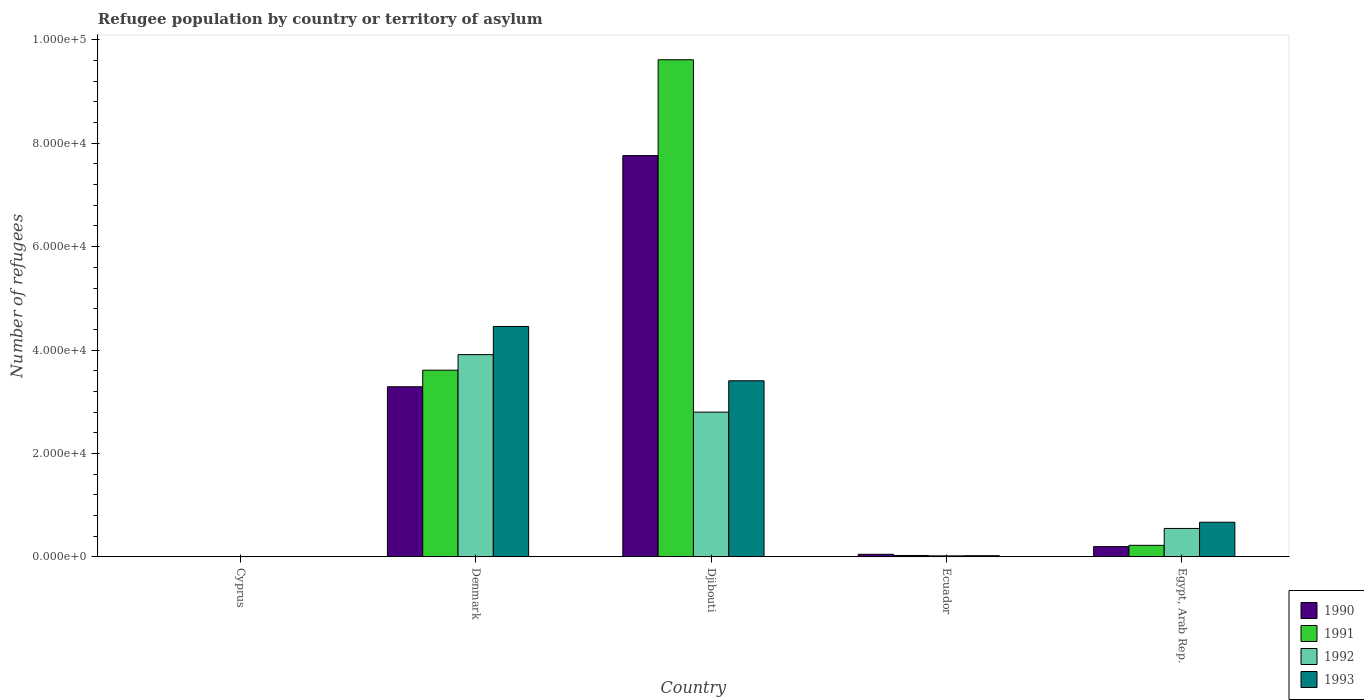How many different coloured bars are there?
Offer a very short reply. 4. How many groups of bars are there?
Make the answer very short. 5. Are the number of bars on each tick of the X-axis equal?
Offer a very short reply. Yes. How many bars are there on the 1st tick from the right?
Your response must be concise. 4. What is the label of the 1st group of bars from the left?
Offer a terse response. Cyprus. What is the number of refugees in 1992 in Djibouti?
Make the answer very short. 2.80e+04. Across all countries, what is the maximum number of refugees in 1990?
Offer a very short reply. 7.76e+04. Across all countries, what is the minimum number of refugees in 1993?
Keep it short and to the point. 82. In which country was the number of refugees in 1990 maximum?
Your response must be concise. Djibouti. In which country was the number of refugees in 1990 minimum?
Keep it short and to the point. Cyprus. What is the total number of refugees in 1991 in the graph?
Your response must be concise. 1.35e+05. What is the difference between the number of refugees in 1992 in Djibouti and that in Ecuador?
Offer a very short reply. 2.78e+04. What is the difference between the number of refugees in 1991 in Djibouti and the number of refugees in 1993 in Ecuador?
Your answer should be compact. 9.59e+04. What is the average number of refugees in 1993 per country?
Your answer should be compact. 1.71e+04. What is the difference between the number of refugees of/in 1992 and number of refugees of/in 1990 in Egypt, Arab Rep.?
Make the answer very short. 3518. What is the ratio of the number of refugees in 1990 in Djibouti to that in Egypt, Arab Rep.?
Make the answer very short. 38.98. Is the number of refugees in 1993 in Denmark less than that in Djibouti?
Your answer should be very brief. No. Is the difference between the number of refugees in 1992 in Djibouti and Egypt, Arab Rep. greater than the difference between the number of refugees in 1990 in Djibouti and Egypt, Arab Rep.?
Offer a terse response. No. What is the difference between the highest and the second highest number of refugees in 1991?
Give a very brief answer. 9.39e+04. What is the difference between the highest and the lowest number of refugees in 1993?
Make the answer very short. 4.45e+04. In how many countries, is the number of refugees in 1990 greater than the average number of refugees in 1990 taken over all countries?
Keep it short and to the point. 2. Is the sum of the number of refugees in 1991 in Denmark and Ecuador greater than the maximum number of refugees in 1990 across all countries?
Provide a succinct answer. No. Is it the case that in every country, the sum of the number of refugees in 1993 and number of refugees in 1991 is greater than the sum of number of refugees in 1992 and number of refugees in 1990?
Make the answer very short. No. What does the 4th bar from the left in Denmark represents?
Offer a terse response. 1993. Is it the case that in every country, the sum of the number of refugees in 1993 and number of refugees in 1992 is greater than the number of refugees in 1991?
Offer a terse response. No. How many bars are there?
Make the answer very short. 20. Are all the bars in the graph horizontal?
Make the answer very short. No. What is the difference between two consecutive major ticks on the Y-axis?
Keep it short and to the point. 2.00e+04. Are the values on the major ticks of Y-axis written in scientific E-notation?
Offer a terse response. Yes. Does the graph contain any zero values?
Your answer should be very brief. No. Where does the legend appear in the graph?
Your response must be concise. Bottom right. How many legend labels are there?
Provide a short and direct response. 4. How are the legend labels stacked?
Provide a succinct answer. Vertical. What is the title of the graph?
Your response must be concise. Refugee population by country or territory of asylum. What is the label or title of the X-axis?
Your answer should be compact. Country. What is the label or title of the Y-axis?
Provide a short and direct response. Number of refugees. What is the Number of refugees of 1990 in Cyprus?
Provide a short and direct response. 33. What is the Number of refugees in 1991 in Cyprus?
Provide a short and direct response. 60. What is the Number of refugees in 1992 in Cyprus?
Your answer should be compact. 80. What is the Number of refugees in 1990 in Denmark?
Your answer should be very brief. 3.29e+04. What is the Number of refugees of 1991 in Denmark?
Your answer should be very brief. 3.61e+04. What is the Number of refugees of 1992 in Denmark?
Give a very brief answer. 3.91e+04. What is the Number of refugees of 1993 in Denmark?
Keep it short and to the point. 4.46e+04. What is the Number of refugees in 1990 in Djibouti?
Ensure brevity in your answer.  7.76e+04. What is the Number of refugees of 1991 in Djibouti?
Your answer should be very brief. 9.61e+04. What is the Number of refugees of 1992 in Djibouti?
Your answer should be very brief. 2.80e+04. What is the Number of refugees of 1993 in Djibouti?
Give a very brief answer. 3.41e+04. What is the Number of refugees in 1990 in Ecuador?
Ensure brevity in your answer.  510. What is the Number of refugees of 1991 in Ecuador?
Your response must be concise. 280. What is the Number of refugees of 1992 in Ecuador?
Make the answer very short. 204. What is the Number of refugees in 1993 in Ecuador?
Provide a succinct answer. 238. What is the Number of refugees of 1990 in Egypt, Arab Rep.?
Ensure brevity in your answer.  1991. What is the Number of refugees in 1991 in Egypt, Arab Rep.?
Offer a very short reply. 2245. What is the Number of refugees of 1992 in Egypt, Arab Rep.?
Your response must be concise. 5509. What is the Number of refugees of 1993 in Egypt, Arab Rep.?
Make the answer very short. 6712. Across all countries, what is the maximum Number of refugees in 1990?
Keep it short and to the point. 7.76e+04. Across all countries, what is the maximum Number of refugees of 1991?
Your answer should be very brief. 9.61e+04. Across all countries, what is the maximum Number of refugees in 1992?
Keep it short and to the point. 3.91e+04. Across all countries, what is the maximum Number of refugees in 1993?
Provide a short and direct response. 4.46e+04. Across all countries, what is the minimum Number of refugees in 1990?
Offer a very short reply. 33. Across all countries, what is the minimum Number of refugees in 1992?
Keep it short and to the point. 80. What is the total Number of refugees of 1990 in the graph?
Ensure brevity in your answer.  1.13e+05. What is the total Number of refugees of 1991 in the graph?
Provide a short and direct response. 1.35e+05. What is the total Number of refugees in 1992 in the graph?
Offer a very short reply. 7.29e+04. What is the total Number of refugees in 1993 in the graph?
Provide a short and direct response. 8.57e+04. What is the difference between the Number of refugees in 1990 in Cyprus and that in Denmark?
Offer a very short reply. -3.29e+04. What is the difference between the Number of refugees of 1991 in Cyprus and that in Denmark?
Provide a succinct answer. -3.60e+04. What is the difference between the Number of refugees of 1992 in Cyprus and that in Denmark?
Make the answer very short. -3.90e+04. What is the difference between the Number of refugees of 1993 in Cyprus and that in Denmark?
Provide a short and direct response. -4.45e+04. What is the difference between the Number of refugees of 1990 in Cyprus and that in Djibouti?
Offer a terse response. -7.76e+04. What is the difference between the Number of refugees in 1991 in Cyprus and that in Djibouti?
Give a very brief answer. -9.61e+04. What is the difference between the Number of refugees of 1992 in Cyprus and that in Djibouti?
Provide a succinct answer. -2.79e+04. What is the difference between the Number of refugees in 1993 in Cyprus and that in Djibouti?
Provide a succinct answer. -3.40e+04. What is the difference between the Number of refugees in 1990 in Cyprus and that in Ecuador?
Ensure brevity in your answer.  -477. What is the difference between the Number of refugees in 1991 in Cyprus and that in Ecuador?
Provide a short and direct response. -220. What is the difference between the Number of refugees in 1992 in Cyprus and that in Ecuador?
Your response must be concise. -124. What is the difference between the Number of refugees of 1993 in Cyprus and that in Ecuador?
Offer a very short reply. -156. What is the difference between the Number of refugees in 1990 in Cyprus and that in Egypt, Arab Rep.?
Your answer should be very brief. -1958. What is the difference between the Number of refugees of 1991 in Cyprus and that in Egypt, Arab Rep.?
Offer a very short reply. -2185. What is the difference between the Number of refugees in 1992 in Cyprus and that in Egypt, Arab Rep.?
Give a very brief answer. -5429. What is the difference between the Number of refugees of 1993 in Cyprus and that in Egypt, Arab Rep.?
Provide a succinct answer. -6630. What is the difference between the Number of refugees in 1990 in Denmark and that in Djibouti?
Offer a terse response. -4.47e+04. What is the difference between the Number of refugees of 1991 in Denmark and that in Djibouti?
Your answer should be very brief. -6.00e+04. What is the difference between the Number of refugees of 1992 in Denmark and that in Djibouti?
Provide a succinct answer. 1.11e+04. What is the difference between the Number of refugees in 1993 in Denmark and that in Djibouti?
Provide a succinct answer. 1.05e+04. What is the difference between the Number of refugees in 1990 in Denmark and that in Ecuador?
Ensure brevity in your answer.  3.24e+04. What is the difference between the Number of refugees of 1991 in Denmark and that in Ecuador?
Make the answer very short. 3.58e+04. What is the difference between the Number of refugees in 1992 in Denmark and that in Ecuador?
Provide a short and direct response. 3.89e+04. What is the difference between the Number of refugees of 1993 in Denmark and that in Ecuador?
Offer a terse response. 4.43e+04. What is the difference between the Number of refugees in 1990 in Denmark and that in Egypt, Arab Rep.?
Your answer should be very brief. 3.09e+04. What is the difference between the Number of refugees in 1991 in Denmark and that in Egypt, Arab Rep.?
Ensure brevity in your answer.  3.39e+04. What is the difference between the Number of refugees of 1992 in Denmark and that in Egypt, Arab Rep.?
Give a very brief answer. 3.36e+04. What is the difference between the Number of refugees of 1993 in Denmark and that in Egypt, Arab Rep.?
Your answer should be compact. 3.79e+04. What is the difference between the Number of refugees in 1990 in Djibouti and that in Ecuador?
Provide a short and direct response. 7.71e+04. What is the difference between the Number of refugees in 1991 in Djibouti and that in Ecuador?
Ensure brevity in your answer.  9.59e+04. What is the difference between the Number of refugees of 1992 in Djibouti and that in Ecuador?
Your answer should be compact. 2.78e+04. What is the difference between the Number of refugees in 1993 in Djibouti and that in Ecuador?
Provide a succinct answer. 3.38e+04. What is the difference between the Number of refugees in 1990 in Djibouti and that in Egypt, Arab Rep.?
Provide a succinct answer. 7.56e+04. What is the difference between the Number of refugees in 1991 in Djibouti and that in Egypt, Arab Rep.?
Offer a very short reply. 9.39e+04. What is the difference between the Number of refugees of 1992 in Djibouti and that in Egypt, Arab Rep.?
Your answer should be very brief. 2.25e+04. What is the difference between the Number of refugees of 1993 in Djibouti and that in Egypt, Arab Rep.?
Provide a short and direct response. 2.74e+04. What is the difference between the Number of refugees of 1990 in Ecuador and that in Egypt, Arab Rep.?
Provide a succinct answer. -1481. What is the difference between the Number of refugees of 1991 in Ecuador and that in Egypt, Arab Rep.?
Your answer should be very brief. -1965. What is the difference between the Number of refugees in 1992 in Ecuador and that in Egypt, Arab Rep.?
Your answer should be compact. -5305. What is the difference between the Number of refugees of 1993 in Ecuador and that in Egypt, Arab Rep.?
Keep it short and to the point. -6474. What is the difference between the Number of refugees of 1990 in Cyprus and the Number of refugees of 1991 in Denmark?
Your answer should be compact. -3.61e+04. What is the difference between the Number of refugees of 1990 in Cyprus and the Number of refugees of 1992 in Denmark?
Your answer should be compact. -3.91e+04. What is the difference between the Number of refugees in 1990 in Cyprus and the Number of refugees in 1993 in Denmark?
Provide a succinct answer. -4.45e+04. What is the difference between the Number of refugees in 1991 in Cyprus and the Number of refugees in 1992 in Denmark?
Ensure brevity in your answer.  -3.91e+04. What is the difference between the Number of refugees of 1991 in Cyprus and the Number of refugees of 1993 in Denmark?
Make the answer very short. -4.45e+04. What is the difference between the Number of refugees of 1992 in Cyprus and the Number of refugees of 1993 in Denmark?
Your answer should be very brief. -4.45e+04. What is the difference between the Number of refugees in 1990 in Cyprus and the Number of refugees in 1991 in Djibouti?
Give a very brief answer. -9.61e+04. What is the difference between the Number of refugees of 1990 in Cyprus and the Number of refugees of 1992 in Djibouti?
Ensure brevity in your answer.  -2.80e+04. What is the difference between the Number of refugees in 1990 in Cyprus and the Number of refugees in 1993 in Djibouti?
Offer a very short reply. -3.40e+04. What is the difference between the Number of refugees of 1991 in Cyprus and the Number of refugees of 1992 in Djibouti?
Give a very brief answer. -2.79e+04. What is the difference between the Number of refugees in 1991 in Cyprus and the Number of refugees in 1993 in Djibouti?
Your answer should be very brief. -3.40e+04. What is the difference between the Number of refugees of 1992 in Cyprus and the Number of refugees of 1993 in Djibouti?
Your response must be concise. -3.40e+04. What is the difference between the Number of refugees in 1990 in Cyprus and the Number of refugees in 1991 in Ecuador?
Provide a succinct answer. -247. What is the difference between the Number of refugees of 1990 in Cyprus and the Number of refugees of 1992 in Ecuador?
Ensure brevity in your answer.  -171. What is the difference between the Number of refugees in 1990 in Cyprus and the Number of refugees in 1993 in Ecuador?
Offer a terse response. -205. What is the difference between the Number of refugees of 1991 in Cyprus and the Number of refugees of 1992 in Ecuador?
Provide a succinct answer. -144. What is the difference between the Number of refugees in 1991 in Cyprus and the Number of refugees in 1993 in Ecuador?
Give a very brief answer. -178. What is the difference between the Number of refugees in 1992 in Cyprus and the Number of refugees in 1993 in Ecuador?
Ensure brevity in your answer.  -158. What is the difference between the Number of refugees of 1990 in Cyprus and the Number of refugees of 1991 in Egypt, Arab Rep.?
Provide a short and direct response. -2212. What is the difference between the Number of refugees in 1990 in Cyprus and the Number of refugees in 1992 in Egypt, Arab Rep.?
Ensure brevity in your answer.  -5476. What is the difference between the Number of refugees of 1990 in Cyprus and the Number of refugees of 1993 in Egypt, Arab Rep.?
Keep it short and to the point. -6679. What is the difference between the Number of refugees of 1991 in Cyprus and the Number of refugees of 1992 in Egypt, Arab Rep.?
Your answer should be compact. -5449. What is the difference between the Number of refugees of 1991 in Cyprus and the Number of refugees of 1993 in Egypt, Arab Rep.?
Provide a short and direct response. -6652. What is the difference between the Number of refugees in 1992 in Cyprus and the Number of refugees in 1993 in Egypt, Arab Rep.?
Provide a short and direct response. -6632. What is the difference between the Number of refugees in 1990 in Denmark and the Number of refugees in 1991 in Djibouti?
Your answer should be very brief. -6.32e+04. What is the difference between the Number of refugees of 1990 in Denmark and the Number of refugees of 1992 in Djibouti?
Keep it short and to the point. 4906. What is the difference between the Number of refugees of 1990 in Denmark and the Number of refugees of 1993 in Djibouti?
Offer a terse response. -1159. What is the difference between the Number of refugees of 1991 in Denmark and the Number of refugees of 1992 in Djibouti?
Provide a succinct answer. 8110. What is the difference between the Number of refugees of 1991 in Denmark and the Number of refugees of 1993 in Djibouti?
Offer a terse response. 2045. What is the difference between the Number of refugees of 1992 in Denmark and the Number of refugees of 1993 in Djibouti?
Ensure brevity in your answer.  5053. What is the difference between the Number of refugees in 1990 in Denmark and the Number of refugees in 1991 in Ecuador?
Offer a terse response. 3.26e+04. What is the difference between the Number of refugees of 1990 in Denmark and the Number of refugees of 1992 in Ecuador?
Make the answer very short. 3.27e+04. What is the difference between the Number of refugees of 1990 in Denmark and the Number of refugees of 1993 in Ecuador?
Your answer should be compact. 3.27e+04. What is the difference between the Number of refugees of 1991 in Denmark and the Number of refugees of 1992 in Ecuador?
Your answer should be compact. 3.59e+04. What is the difference between the Number of refugees in 1991 in Denmark and the Number of refugees in 1993 in Ecuador?
Offer a terse response. 3.59e+04. What is the difference between the Number of refugees of 1992 in Denmark and the Number of refugees of 1993 in Ecuador?
Your response must be concise. 3.89e+04. What is the difference between the Number of refugees of 1990 in Denmark and the Number of refugees of 1991 in Egypt, Arab Rep.?
Offer a very short reply. 3.07e+04. What is the difference between the Number of refugees in 1990 in Denmark and the Number of refugees in 1992 in Egypt, Arab Rep.?
Provide a succinct answer. 2.74e+04. What is the difference between the Number of refugees in 1990 in Denmark and the Number of refugees in 1993 in Egypt, Arab Rep.?
Offer a terse response. 2.62e+04. What is the difference between the Number of refugees in 1991 in Denmark and the Number of refugees in 1992 in Egypt, Arab Rep.?
Your response must be concise. 3.06e+04. What is the difference between the Number of refugees in 1991 in Denmark and the Number of refugees in 1993 in Egypt, Arab Rep.?
Your answer should be very brief. 2.94e+04. What is the difference between the Number of refugees in 1992 in Denmark and the Number of refugees in 1993 in Egypt, Arab Rep.?
Provide a short and direct response. 3.24e+04. What is the difference between the Number of refugees of 1990 in Djibouti and the Number of refugees of 1991 in Ecuador?
Offer a terse response. 7.73e+04. What is the difference between the Number of refugees of 1990 in Djibouti and the Number of refugees of 1992 in Ecuador?
Provide a short and direct response. 7.74e+04. What is the difference between the Number of refugees in 1990 in Djibouti and the Number of refugees in 1993 in Ecuador?
Your response must be concise. 7.74e+04. What is the difference between the Number of refugees in 1991 in Djibouti and the Number of refugees in 1992 in Ecuador?
Make the answer very short. 9.59e+04. What is the difference between the Number of refugees in 1991 in Djibouti and the Number of refugees in 1993 in Ecuador?
Your response must be concise. 9.59e+04. What is the difference between the Number of refugees in 1992 in Djibouti and the Number of refugees in 1993 in Ecuador?
Keep it short and to the point. 2.78e+04. What is the difference between the Number of refugees in 1990 in Djibouti and the Number of refugees in 1991 in Egypt, Arab Rep.?
Make the answer very short. 7.54e+04. What is the difference between the Number of refugees of 1990 in Djibouti and the Number of refugees of 1992 in Egypt, Arab Rep.?
Provide a succinct answer. 7.21e+04. What is the difference between the Number of refugees of 1990 in Djibouti and the Number of refugees of 1993 in Egypt, Arab Rep.?
Your answer should be very brief. 7.09e+04. What is the difference between the Number of refugees of 1991 in Djibouti and the Number of refugees of 1992 in Egypt, Arab Rep.?
Your response must be concise. 9.06e+04. What is the difference between the Number of refugees in 1991 in Djibouti and the Number of refugees in 1993 in Egypt, Arab Rep.?
Ensure brevity in your answer.  8.94e+04. What is the difference between the Number of refugees of 1992 in Djibouti and the Number of refugees of 1993 in Egypt, Arab Rep.?
Offer a terse response. 2.13e+04. What is the difference between the Number of refugees in 1990 in Ecuador and the Number of refugees in 1991 in Egypt, Arab Rep.?
Your answer should be very brief. -1735. What is the difference between the Number of refugees in 1990 in Ecuador and the Number of refugees in 1992 in Egypt, Arab Rep.?
Provide a succinct answer. -4999. What is the difference between the Number of refugees of 1990 in Ecuador and the Number of refugees of 1993 in Egypt, Arab Rep.?
Your answer should be compact. -6202. What is the difference between the Number of refugees of 1991 in Ecuador and the Number of refugees of 1992 in Egypt, Arab Rep.?
Ensure brevity in your answer.  -5229. What is the difference between the Number of refugees in 1991 in Ecuador and the Number of refugees in 1993 in Egypt, Arab Rep.?
Give a very brief answer. -6432. What is the difference between the Number of refugees of 1992 in Ecuador and the Number of refugees of 1993 in Egypt, Arab Rep.?
Your answer should be compact. -6508. What is the average Number of refugees of 1990 per country?
Make the answer very short. 2.26e+04. What is the average Number of refugees in 1991 per country?
Your answer should be compact. 2.70e+04. What is the average Number of refugees of 1992 per country?
Provide a short and direct response. 1.46e+04. What is the average Number of refugees of 1993 per country?
Ensure brevity in your answer.  1.71e+04. What is the difference between the Number of refugees of 1990 and Number of refugees of 1991 in Cyprus?
Keep it short and to the point. -27. What is the difference between the Number of refugees of 1990 and Number of refugees of 1992 in Cyprus?
Provide a short and direct response. -47. What is the difference between the Number of refugees in 1990 and Number of refugees in 1993 in Cyprus?
Give a very brief answer. -49. What is the difference between the Number of refugees of 1992 and Number of refugees of 1993 in Cyprus?
Ensure brevity in your answer.  -2. What is the difference between the Number of refugees of 1990 and Number of refugees of 1991 in Denmark?
Your response must be concise. -3204. What is the difference between the Number of refugees of 1990 and Number of refugees of 1992 in Denmark?
Give a very brief answer. -6212. What is the difference between the Number of refugees of 1990 and Number of refugees of 1993 in Denmark?
Your answer should be compact. -1.17e+04. What is the difference between the Number of refugees of 1991 and Number of refugees of 1992 in Denmark?
Provide a short and direct response. -3008. What is the difference between the Number of refugees of 1991 and Number of refugees of 1993 in Denmark?
Provide a short and direct response. -8454. What is the difference between the Number of refugees in 1992 and Number of refugees in 1993 in Denmark?
Provide a short and direct response. -5446. What is the difference between the Number of refugees in 1990 and Number of refugees in 1991 in Djibouti?
Give a very brief answer. -1.85e+04. What is the difference between the Number of refugees of 1990 and Number of refugees of 1992 in Djibouti?
Offer a terse response. 4.96e+04. What is the difference between the Number of refugees in 1990 and Number of refugees in 1993 in Djibouti?
Provide a short and direct response. 4.35e+04. What is the difference between the Number of refugees of 1991 and Number of refugees of 1992 in Djibouti?
Keep it short and to the point. 6.81e+04. What is the difference between the Number of refugees in 1991 and Number of refugees in 1993 in Djibouti?
Ensure brevity in your answer.  6.21e+04. What is the difference between the Number of refugees in 1992 and Number of refugees in 1993 in Djibouti?
Give a very brief answer. -6065. What is the difference between the Number of refugees in 1990 and Number of refugees in 1991 in Ecuador?
Provide a succinct answer. 230. What is the difference between the Number of refugees in 1990 and Number of refugees in 1992 in Ecuador?
Make the answer very short. 306. What is the difference between the Number of refugees of 1990 and Number of refugees of 1993 in Ecuador?
Your answer should be very brief. 272. What is the difference between the Number of refugees in 1992 and Number of refugees in 1993 in Ecuador?
Your answer should be compact. -34. What is the difference between the Number of refugees in 1990 and Number of refugees in 1991 in Egypt, Arab Rep.?
Provide a short and direct response. -254. What is the difference between the Number of refugees of 1990 and Number of refugees of 1992 in Egypt, Arab Rep.?
Provide a short and direct response. -3518. What is the difference between the Number of refugees of 1990 and Number of refugees of 1993 in Egypt, Arab Rep.?
Your answer should be very brief. -4721. What is the difference between the Number of refugees in 1991 and Number of refugees in 1992 in Egypt, Arab Rep.?
Make the answer very short. -3264. What is the difference between the Number of refugees in 1991 and Number of refugees in 1993 in Egypt, Arab Rep.?
Provide a short and direct response. -4467. What is the difference between the Number of refugees in 1992 and Number of refugees in 1993 in Egypt, Arab Rep.?
Ensure brevity in your answer.  -1203. What is the ratio of the Number of refugees of 1990 in Cyprus to that in Denmark?
Your answer should be very brief. 0. What is the ratio of the Number of refugees in 1991 in Cyprus to that in Denmark?
Your answer should be very brief. 0. What is the ratio of the Number of refugees of 1992 in Cyprus to that in Denmark?
Give a very brief answer. 0. What is the ratio of the Number of refugees in 1993 in Cyprus to that in Denmark?
Offer a terse response. 0. What is the ratio of the Number of refugees of 1990 in Cyprus to that in Djibouti?
Your answer should be very brief. 0. What is the ratio of the Number of refugees of 1991 in Cyprus to that in Djibouti?
Give a very brief answer. 0. What is the ratio of the Number of refugees in 1992 in Cyprus to that in Djibouti?
Offer a very short reply. 0. What is the ratio of the Number of refugees in 1993 in Cyprus to that in Djibouti?
Offer a very short reply. 0. What is the ratio of the Number of refugees of 1990 in Cyprus to that in Ecuador?
Your answer should be very brief. 0.06. What is the ratio of the Number of refugees in 1991 in Cyprus to that in Ecuador?
Your answer should be very brief. 0.21. What is the ratio of the Number of refugees in 1992 in Cyprus to that in Ecuador?
Make the answer very short. 0.39. What is the ratio of the Number of refugees in 1993 in Cyprus to that in Ecuador?
Keep it short and to the point. 0.34. What is the ratio of the Number of refugees of 1990 in Cyprus to that in Egypt, Arab Rep.?
Your answer should be compact. 0.02. What is the ratio of the Number of refugees in 1991 in Cyprus to that in Egypt, Arab Rep.?
Your answer should be compact. 0.03. What is the ratio of the Number of refugees in 1992 in Cyprus to that in Egypt, Arab Rep.?
Offer a very short reply. 0.01. What is the ratio of the Number of refugees in 1993 in Cyprus to that in Egypt, Arab Rep.?
Ensure brevity in your answer.  0.01. What is the ratio of the Number of refugees of 1990 in Denmark to that in Djibouti?
Your answer should be very brief. 0.42. What is the ratio of the Number of refugees of 1991 in Denmark to that in Djibouti?
Keep it short and to the point. 0.38. What is the ratio of the Number of refugees of 1992 in Denmark to that in Djibouti?
Ensure brevity in your answer.  1.4. What is the ratio of the Number of refugees in 1993 in Denmark to that in Djibouti?
Provide a short and direct response. 1.31. What is the ratio of the Number of refugees in 1990 in Denmark to that in Ecuador?
Provide a short and direct response. 64.52. What is the ratio of the Number of refugees of 1991 in Denmark to that in Ecuador?
Make the answer very short. 128.96. What is the ratio of the Number of refugees of 1992 in Denmark to that in Ecuador?
Provide a short and direct response. 191.75. What is the ratio of the Number of refugees of 1993 in Denmark to that in Ecuador?
Give a very brief answer. 187.24. What is the ratio of the Number of refugees in 1990 in Denmark to that in Egypt, Arab Rep.?
Your answer should be very brief. 16.53. What is the ratio of the Number of refugees of 1991 in Denmark to that in Egypt, Arab Rep.?
Your answer should be compact. 16.08. What is the ratio of the Number of refugees of 1992 in Denmark to that in Egypt, Arab Rep.?
Give a very brief answer. 7.1. What is the ratio of the Number of refugees of 1993 in Denmark to that in Egypt, Arab Rep.?
Provide a succinct answer. 6.64. What is the ratio of the Number of refugees in 1990 in Djibouti to that in Ecuador?
Provide a succinct answer. 152.17. What is the ratio of the Number of refugees of 1991 in Djibouti to that in Ecuador?
Your response must be concise. 343.37. What is the ratio of the Number of refugees of 1992 in Djibouti to that in Ecuador?
Your response must be concise. 137.25. What is the ratio of the Number of refugees of 1993 in Djibouti to that in Ecuador?
Make the answer very short. 143.13. What is the ratio of the Number of refugees in 1990 in Djibouti to that in Egypt, Arab Rep.?
Provide a short and direct response. 38.98. What is the ratio of the Number of refugees of 1991 in Djibouti to that in Egypt, Arab Rep.?
Provide a short and direct response. 42.83. What is the ratio of the Number of refugees of 1992 in Djibouti to that in Egypt, Arab Rep.?
Ensure brevity in your answer.  5.08. What is the ratio of the Number of refugees of 1993 in Djibouti to that in Egypt, Arab Rep.?
Your response must be concise. 5.08. What is the ratio of the Number of refugees of 1990 in Ecuador to that in Egypt, Arab Rep.?
Offer a very short reply. 0.26. What is the ratio of the Number of refugees in 1991 in Ecuador to that in Egypt, Arab Rep.?
Make the answer very short. 0.12. What is the ratio of the Number of refugees of 1992 in Ecuador to that in Egypt, Arab Rep.?
Offer a terse response. 0.04. What is the ratio of the Number of refugees of 1993 in Ecuador to that in Egypt, Arab Rep.?
Provide a succinct answer. 0.04. What is the difference between the highest and the second highest Number of refugees in 1990?
Provide a succinct answer. 4.47e+04. What is the difference between the highest and the second highest Number of refugees in 1991?
Your response must be concise. 6.00e+04. What is the difference between the highest and the second highest Number of refugees in 1992?
Ensure brevity in your answer.  1.11e+04. What is the difference between the highest and the second highest Number of refugees in 1993?
Keep it short and to the point. 1.05e+04. What is the difference between the highest and the lowest Number of refugees of 1990?
Your answer should be very brief. 7.76e+04. What is the difference between the highest and the lowest Number of refugees in 1991?
Offer a terse response. 9.61e+04. What is the difference between the highest and the lowest Number of refugees of 1992?
Keep it short and to the point. 3.90e+04. What is the difference between the highest and the lowest Number of refugees in 1993?
Offer a very short reply. 4.45e+04. 